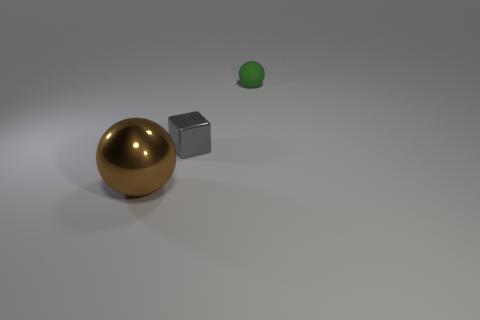Add 2 brown metallic balls. How many objects exist? 5 Subtract all blocks. How many objects are left? 2 Add 2 green matte things. How many green matte things are left? 3 Add 2 small rubber spheres. How many small rubber spheres exist? 3 Subtract 0 purple spheres. How many objects are left? 3 Subtract all balls. Subtract all tiny green balls. How many objects are left? 0 